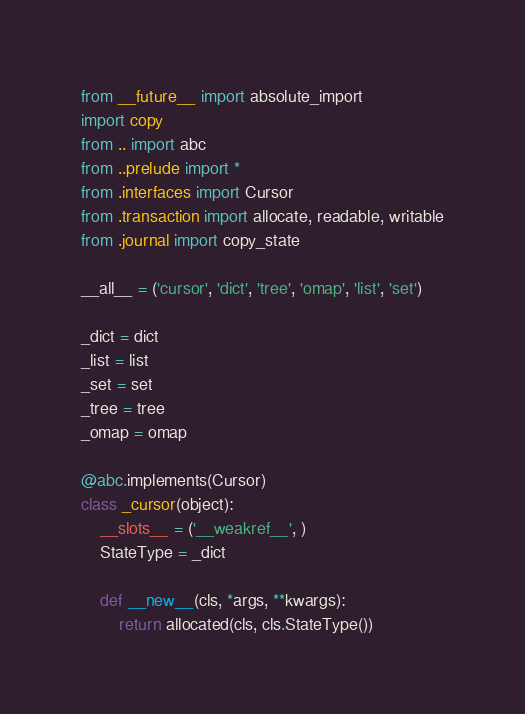<code> <loc_0><loc_0><loc_500><loc_500><_Python_>from __future__ import absolute_import
import copy
from .. import abc
from ..prelude import *
from .interfaces import Cursor
from .transaction import allocate, readable, writable
from .journal import copy_state

__all__ = ('cursor', 'dict', 'tree', 'omap', 'list', 'set')

_dict = dict
_list = list
_set = set
_tree = tree
_omap = omap

@abc.implements(Cursor)
class _cursor(object):
    __slots__ = ('__weakref__', )
    StateType = _dict

    def __new__(cls, *args, **kwargs):
        return allocated(cls, cls.StateType())
</code> 